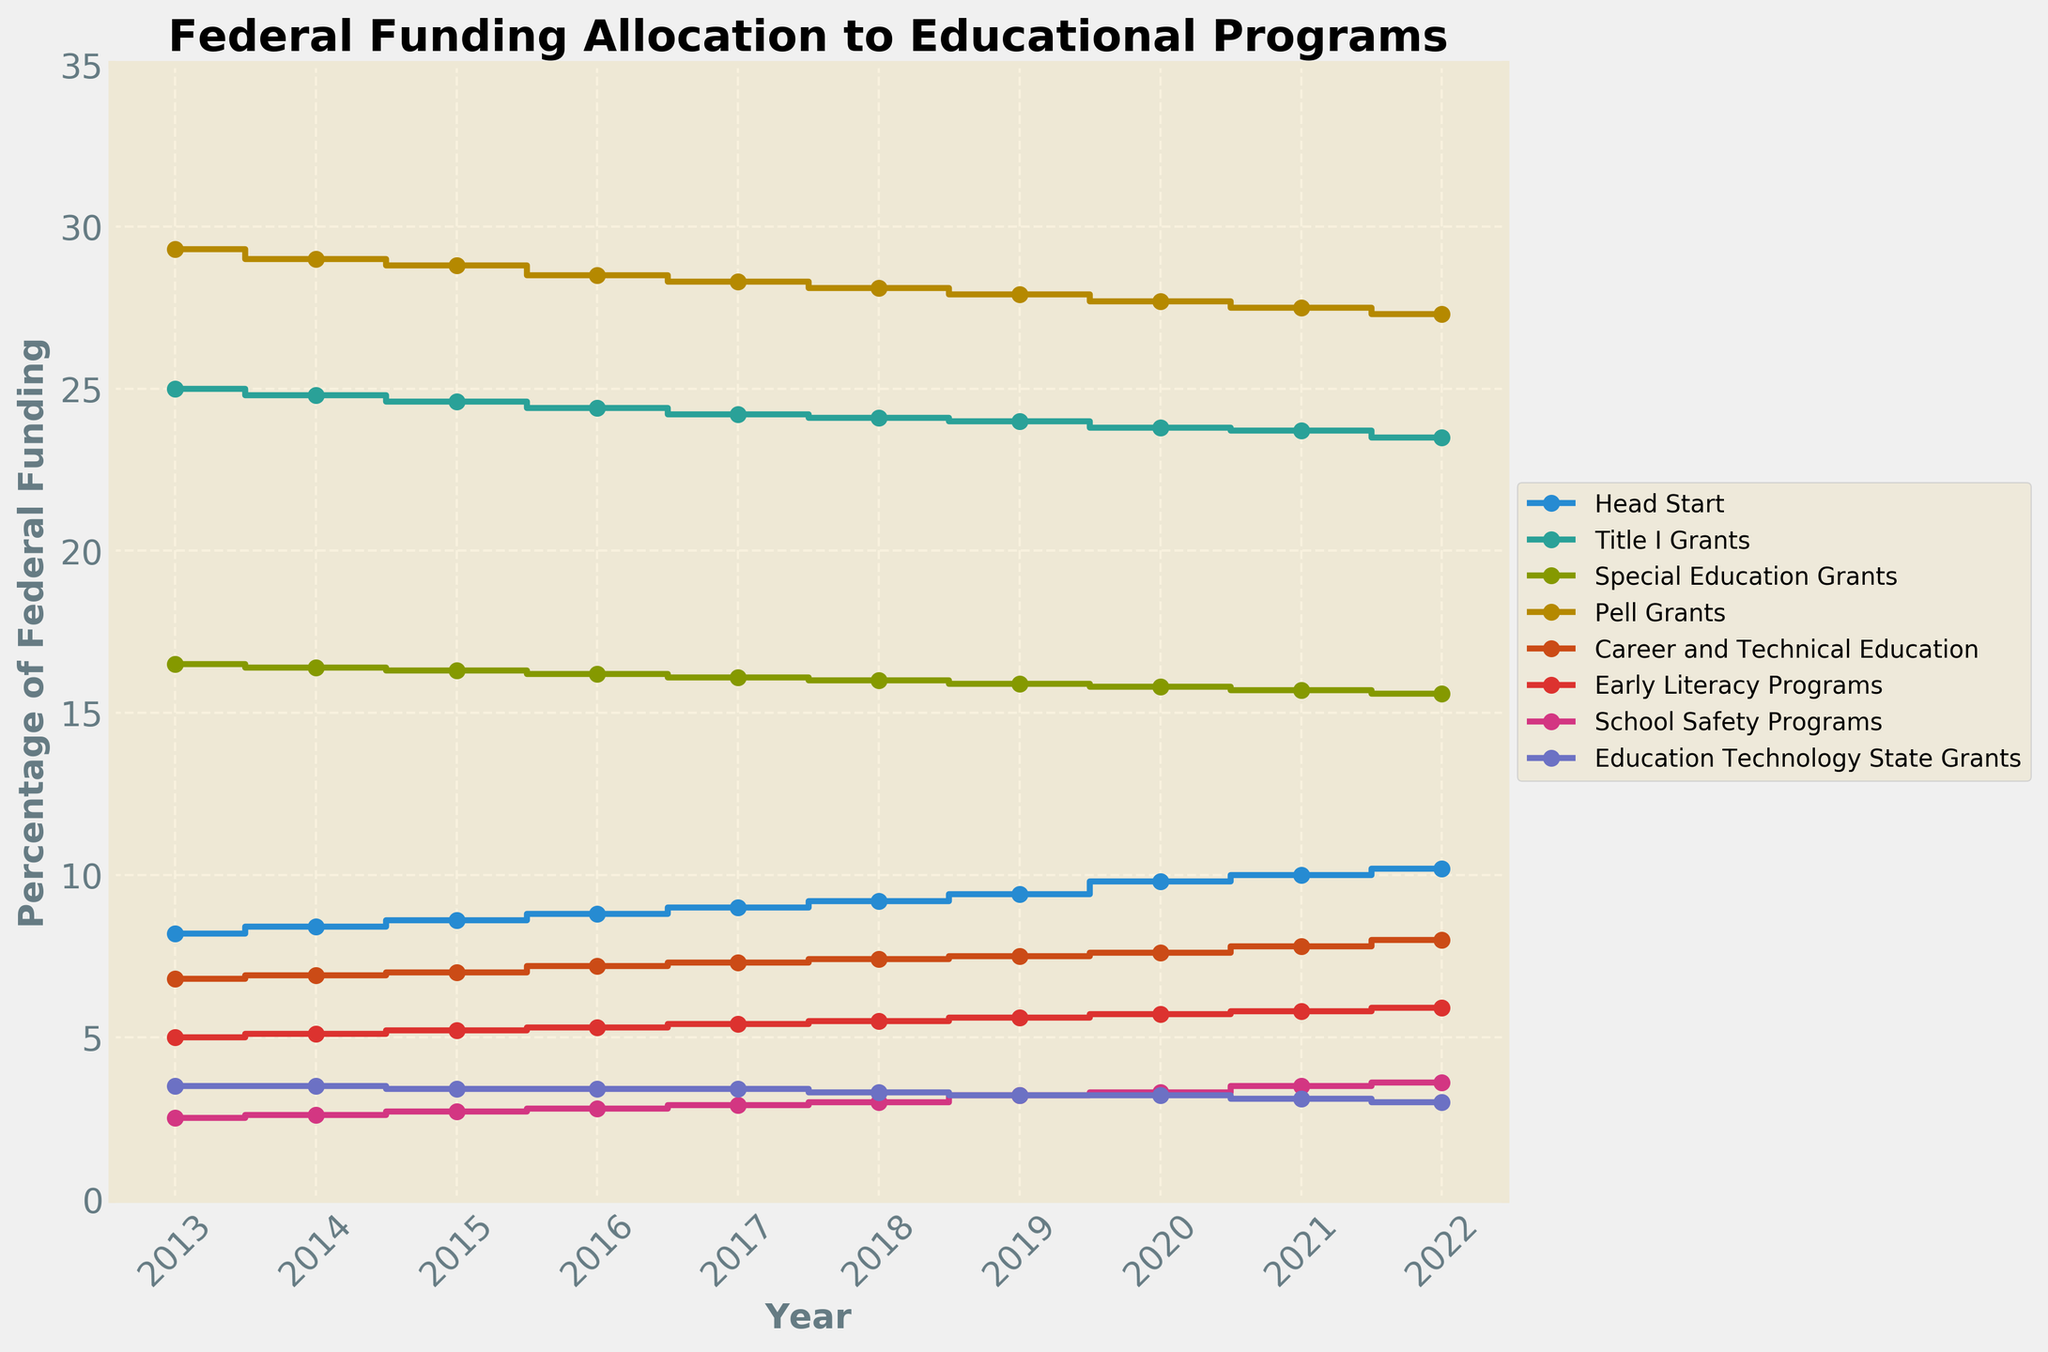What is the title of the figure? The title of a figure is usually at the top and gives an overview of what the chart represents. Here it says "Federal Funding Allocation to Educational Programs".
Answer: Federal Funding Allocation to Educational Programs Between which years is the data displayed in the plot? The x-axis of the plot represents years. Here, the plot shows the data from the year 2013 to the year 2022.
Answer: 2013 to 2022 Which program received the lowest percentage of federal funding in 2022? To find this, look at the 2022 data points for all programs shown in the plot. The program with the lowest percentage is Education Technology State Grants at 3.0%.
Answer: Education Technology State Grants How did the funding for Head Start change over the decade? Observing the plot for Head Start, the percentage increased steadily from 8.2% in 2013 to 10.2% in 2022.
Answer: Increased Which program had the highest percentage of federal funding allocation in 2017? Look at the data points for the year 2017. Pell Grants had the highest percentage at 28.3%.
Answer: Pell Grants Compare the funding trends of Title I Grants and Head Start over the decade. Title I Grants showed a decreasing trend from 25.0% to 23.5%, whereas Head Start showed an increasing trend from 8.2% to 10.2%.
Answer: Title I Grants decreased, Head Start increased What was the approximate change in funding percentage for Career and Technical Education from 2013 to 2022? The funding percentage for Career and Technical Education increased from 6.8% in 2013 to 8.0% in 2022, so a change of approximately 1.2%.
Answer: 1.2% Calculate the average percentage of federal funding for Early Literacy Programs over the decade. Sum the percentages for each year from 2013 to 2022 (5.0 + 5.1 + 5.2 + 5.3 + 5.4 + 5.5 + 5.6 + 5.7 + 5.8 + 5.9) = 54.5. Divide by the number of years (10). The average is 54.5 / 10 = 5.45%.
Answer: 5.45% Between which years did School Safety Programs see the largest increase in funding percentage? Identify the years with the largest jump in percentage for School Safety Programs data points. The largest increase occurred between 2018 (3.0%) and 2019 (3.2%).
Answer: 2018 and 2019 